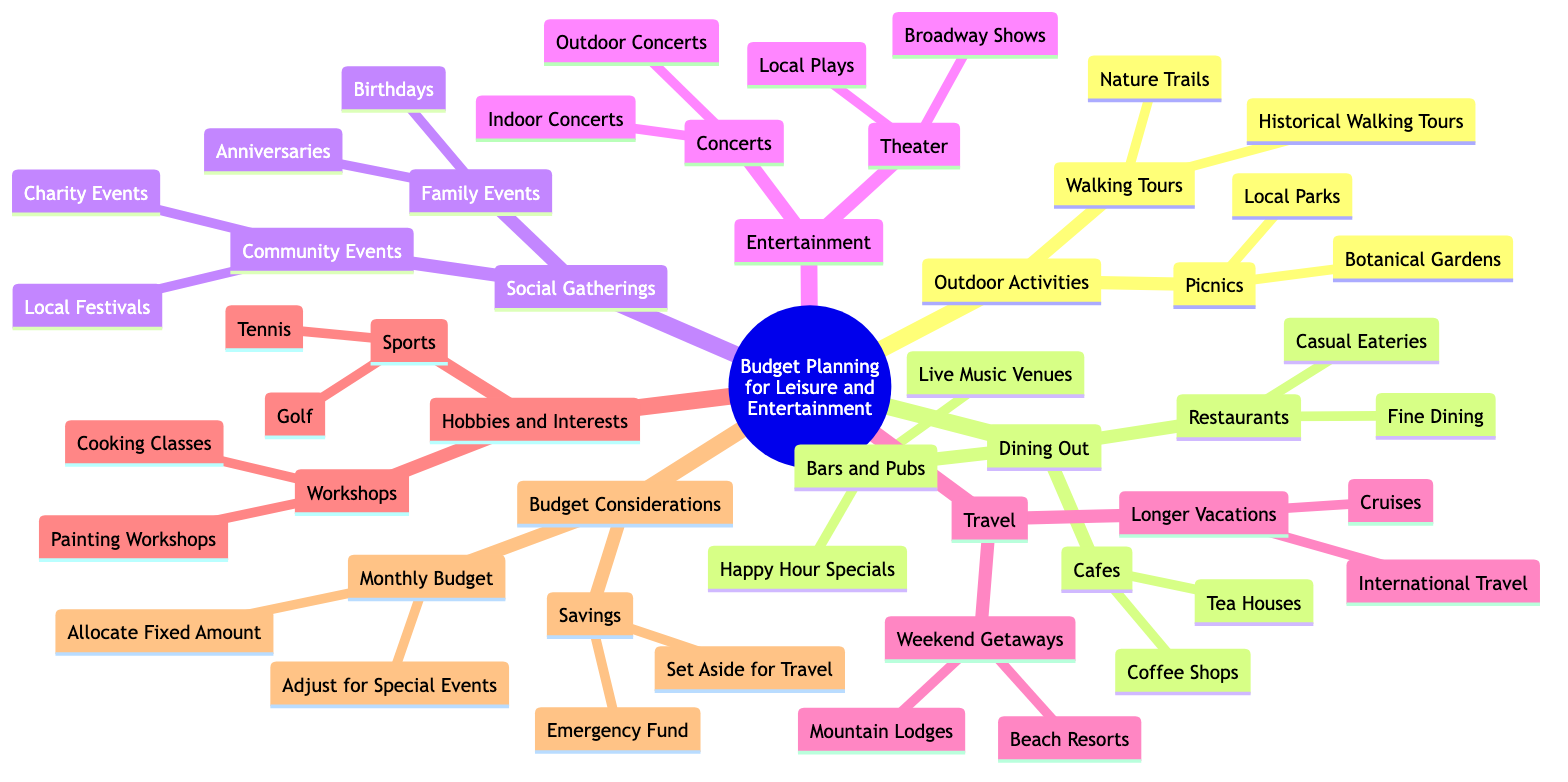What are the categories included in Budget Planning for Leisure and Entertainment? The main categories can be identified at the first-level nodes branching out from the root. These categories are: Outdoor Activities, Dining Out, Social Gatherings, Entertainment, Travel, Hobbies and Interests, and Budget Considerations.
Answer: Outdoor Activities, Dining Out, Social Gatherings, Entertainment, Travel, Hobbies and Interests, Budget Considerations How many types of outdoor activities are listed? The 'Outdoor Activities' node branches into two sub-nodes: Walking Tours and Picnics. Each sub-node has additional elements, but the count of main types is simply two.
Answer: 2 What are the types of events under Social Gatherings? Under the 'Social Gatherings' category, there are two sub-categories: 'Family Events' and 'Community Events'. Each of these has its own specific types, but the primary types are just the two main sub-categories.
Answer: Family Events, Community Events Which dining option has a type of event tied to music? Under 'Dining Out', the 'Bars and Pubs' node specifically mentions 'Live Music Venues'. Thereby indicating that one of the options under dining is related to music.
Answer: Live Music Venues Do Weekend Getaways and Longer Vacations fall under the same category? Both 'Weekend Getaways' and 'Longer Vacations' are sub-nodes of the 'Travel' category, which indicates they share the same broader category in the mind map structure.
Answer: Yes What type of workshops are available under Hobbies and Interests? The 'Hobbies and Interests' node includes a sub-node labeled 'Workshops', which contains two types: 'Cooking Classes' and 'Painting Workshops'. Thus referring directly to the available options.
Answer: Cooking Classes, Painting Workshops How does the Monthly Budget node relate to Budget Considerations? The 'Monthly Budget' node is a sub-node under the main 'Budget Considerations' category. This indicates that it is part of planning for the overall budget regarding leisure and entertainment.
Answer: It is a sub-node of Budget Considerations What is one type of entertainment mentioned? The 'Entertainment' category has a major sub-branch for 'Concerts', which includes options for 'Outdoor Concerts' and 'Indoor Concerts', thus indicating a type of entertainment provided in the diagram.
Answer: Concerts 